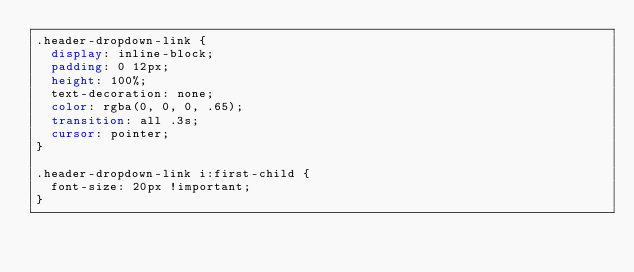<code> <loc_0><loc_0><loc_500><loc_500><_CSS_>.header-dropdown-link {
  display: inline-block;
  padding: 0 12px;
  height: 100%;
  text-decoration: none;
  color: rgba(0, 0, 0, .65);
  transition: all .3s;
  cursor: pointer;
}

.header-dropdown-link i:first-child {
  font-size: 20px !important;
}</code> 